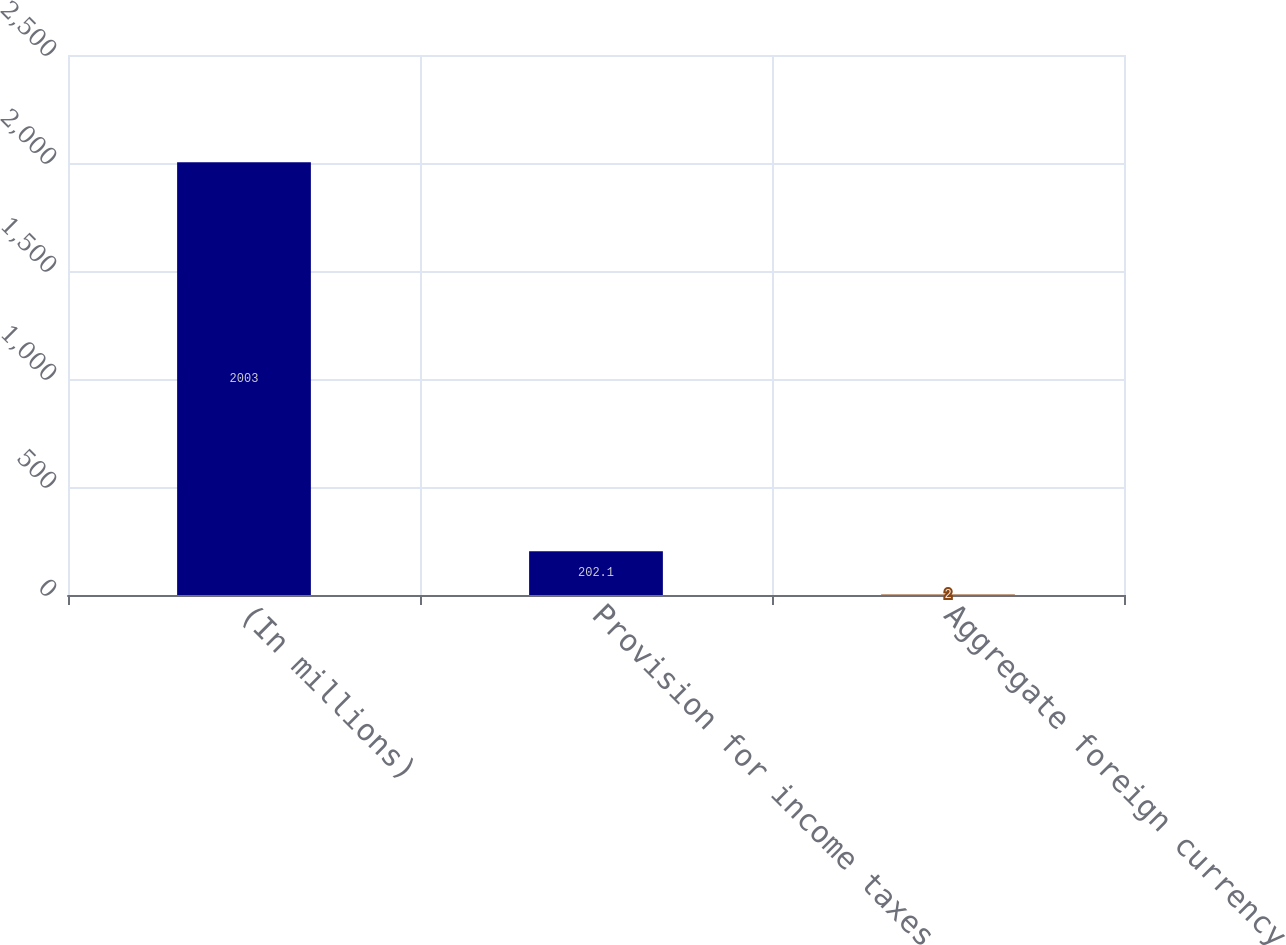Convert chart. <chart><loc_0><loc_0><loc_500><loc_500><bar_chart><fcel>(In millions)<fcel>Provision for income taxes<fcel>Aggregate foreign currency<nl><fcel>2003<fcel>202.1<fcel>2<nl></chart> 